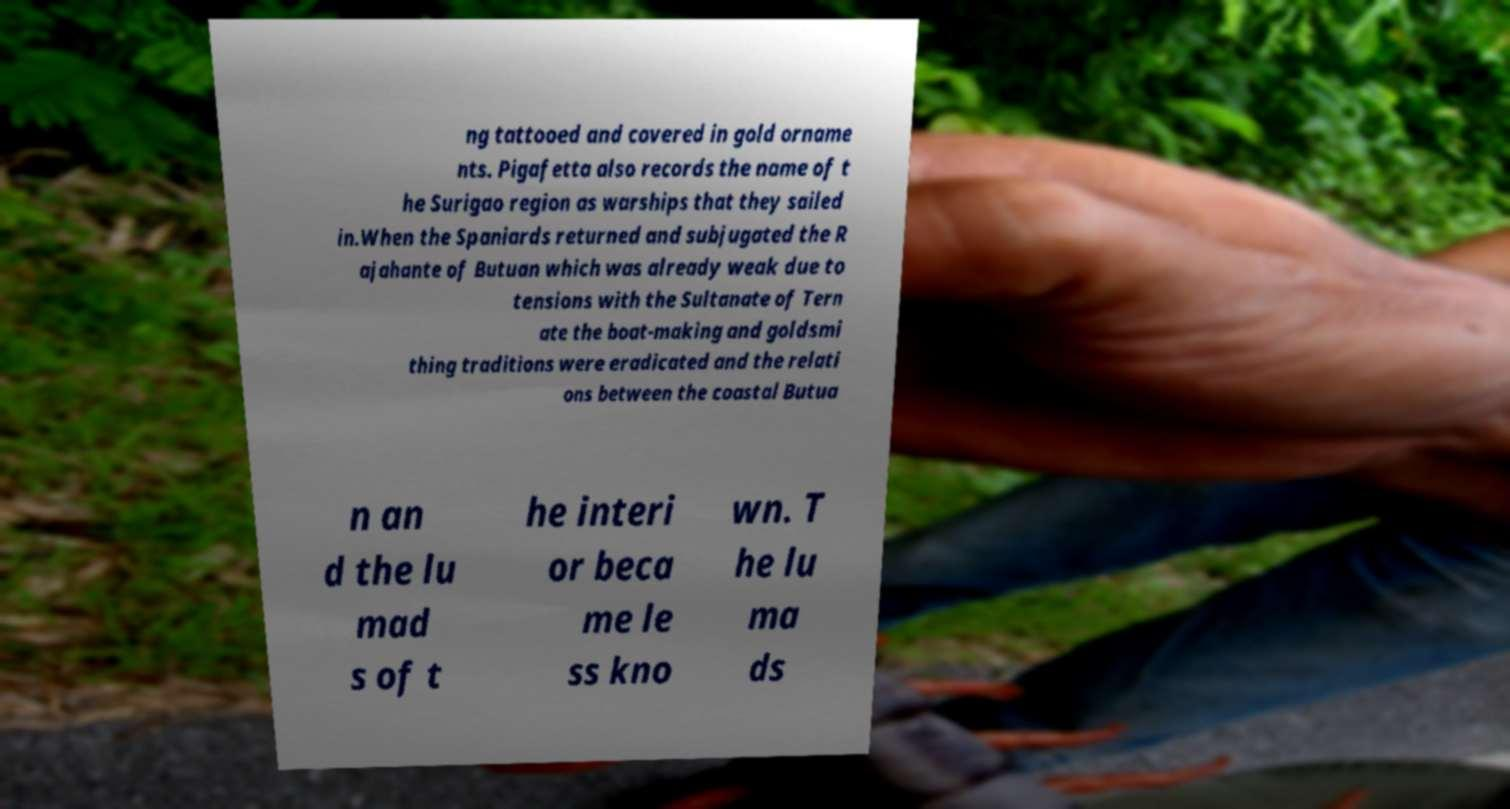Could you extract and type out the text from this image? ng tattooed and covered in gold orname nts. Pigafetta also records the name of t he Surigao region as warships that they sailed in.When the Spaniards returned and subjugated the R ajahante of Butuan which was already weak due to tensions with the Sultanate of Tern ate the boat-making and goldsmi thing traditions were eradicated and the relati ons between the coastal Butua n an d the lu mad s of t he interi or beca me le ss kno wn. T he lu ma ds 